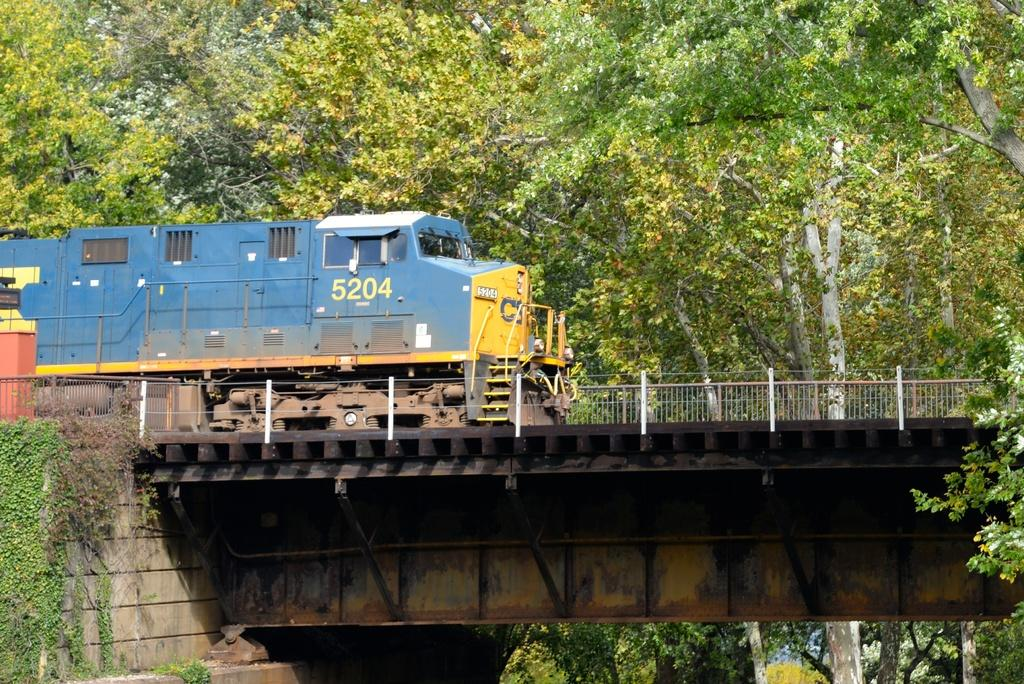<image>
Provide a brief description of the given image. A blue train numbered 5204 passing over a bridge. 